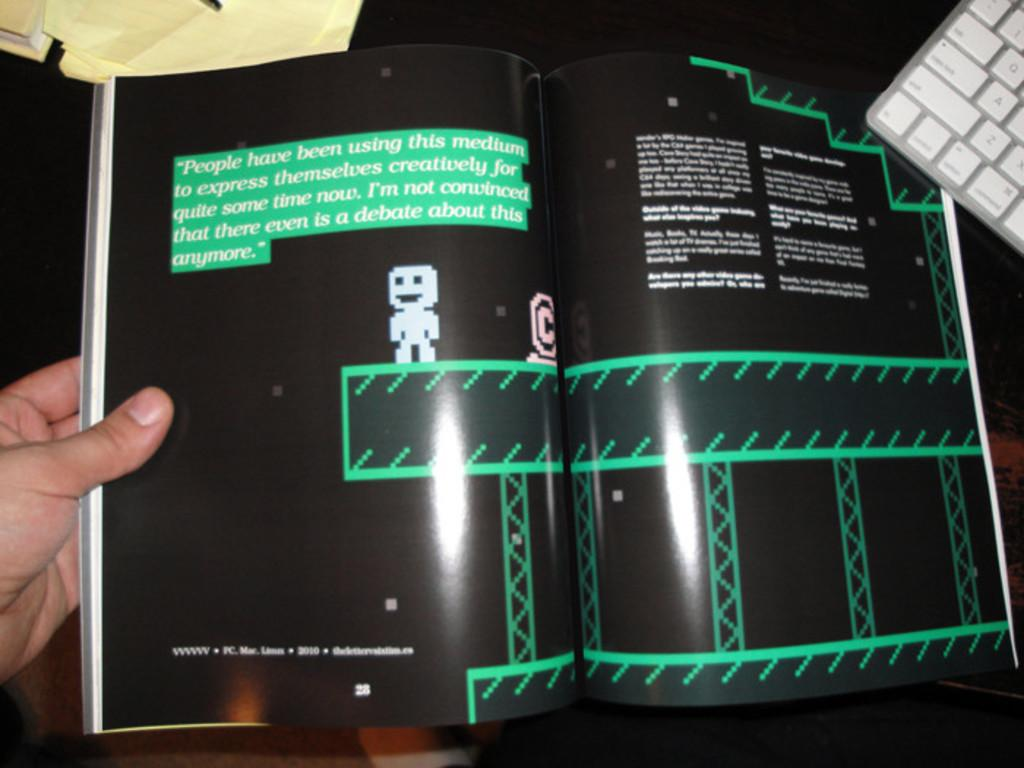<image>
Provide a brief description of the given image. Person holding a magazine that shows a cartoon character and was made in 2010. 